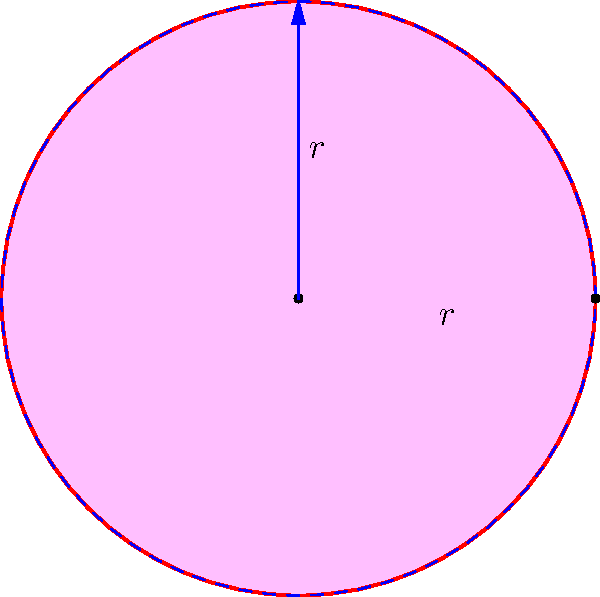A heart-shaped adoption symbol can be approximated by two circles of radius $r$ and a triangle. Calculate the area of this symbol if $r = 2$ cm. To calculate the area of the heart-shaped adoption symbol, we need to:

1. Calculate the area of two circles:
   $$A_{circles} = 2 \times \pi r^2$$

2. Calculate the area of the triangle:
   The base of the triangle is $2r$, and its height is $r$.
   $$A_{triangle} = \frac{1}{2} \times 2r \times r = r^2$$

3. Subtract the area of the triangle from the area of the circles:
   $$A_{heart} = A_{circles} - A_{triangle}$$
   $$A_{heart} = 2\pi r^2 - r^2$$
   $$A_{heart} = (2\pi - 1)r^2$$

4. Substitute $r = 2$ cm:
   $$A_{heart} = (2\pi - 1)(2 \text{ cm})^2$$
   $$A_{heart} = (2\pi - 1)(4 \text{ cm}^2)$$
   $$A_{heart} = (8\pi - 4) \text{ cm}^2$$
   $$A_{heart} \approx 21.13 \text{ cm}^2$$
Answer: $21.13 \text{ cm}^2$ 